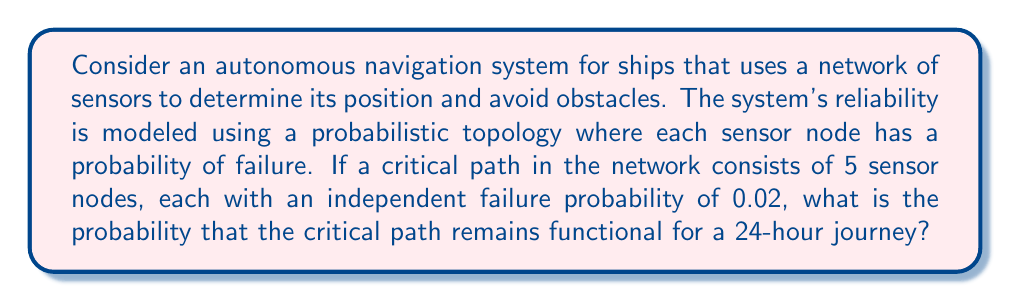Can you solve this math problem? To solve this problem, we need to consider the topological structure of the sensor network and apply probability theory. Let's break it down step-by-step:

1) First, we need to understand what it means for the critical path to remain functional. This occurs when all 5 sensor nodes in the path continue working throughout the journey.

2) The probability of a single sensor node failing is given as 0.02. Therefore, the probability of a single sensor node remaining functional is:

   $P(\text{sensor functional}) = 1 - 0.02 = 0.98$

3) Since we need all 5 sensor nodes to remain functional, and their failures are independent, we can use the multiplication rule of probability. The probability of all 5 sensors remaining functional is:

   $P(\text{all functional}) = 0.98^5$

4) Let's calculate this:

   $0.98^5 \approx 0.9039821$

5) This gives us the probability of the critical path remaining functional for a single moment. However, we need to consider the entire 24-hour journey.

6) In topology, we can model this as a continuous function over time. If we assume that the failure rate is constant over time (which is a common assumption in reliability engineering), we can use the exponential reliability function:

   $R(t) = e^{-\lambda t}$

   where $\lambda$ is the failure rate and $t$ is the time period.

7) In our case, $\lambda = -\ln(0.9039821) / 24$ (because $R(24) = 0.9039821$)

8) Therefore, the probability of the critical path remaining functional for the entire 24-hour journey is:

   $R(24) = e^{-(-\ln(0.9039821) / 24) * 24} = 0.9039821$
Answer: The probability that the critical path remains functional for a 24-hour journey is approximately 0.9040 or 90.40%. 